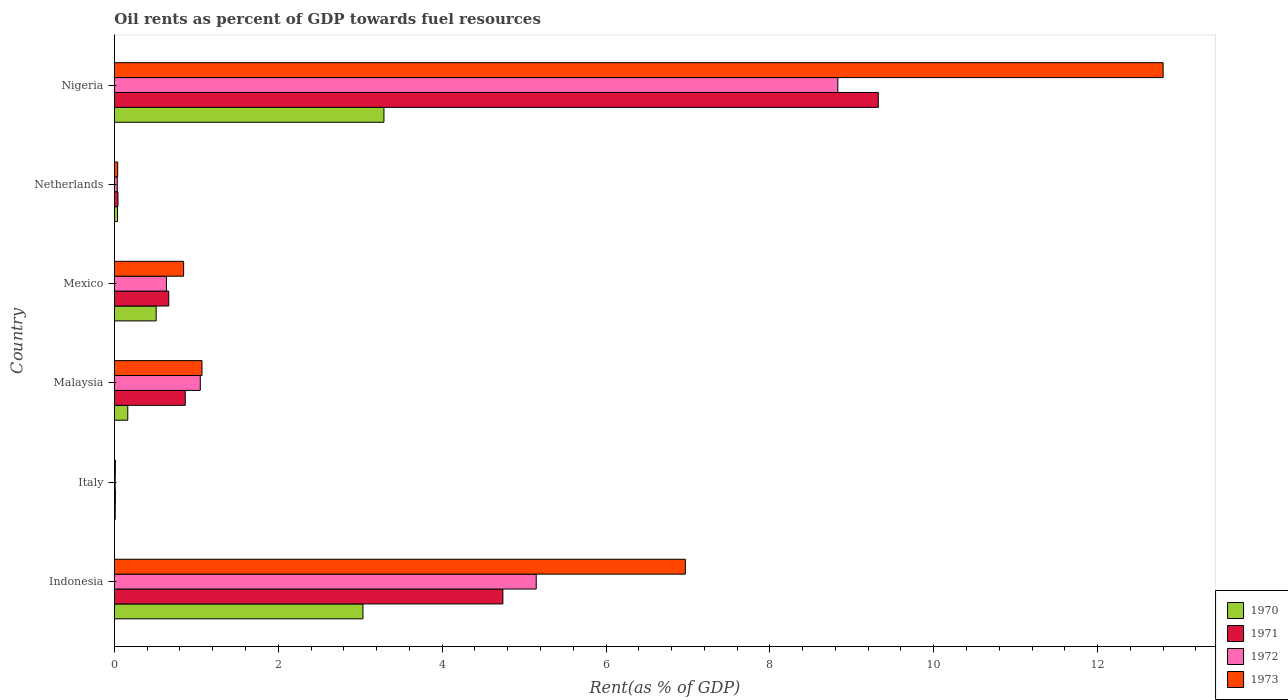How many different coloured bars are there?
Keep it short and to the point. 4. Are the number of bars per tick equal to the number of legend labels?
Provide a short and direct response. Yes. Are the number of bars on each tick of the Y-axis equal?
Your answer should be very brief. Yes. How many bars are there on the 3rd tick from the bottom?
Provide a short and direct response. 4. What is the label of the 3rd group of bars from the top?
Provide a succinct answer. Mexico. In how many cases, is the number of bars for a given country not equal to the number of legend labels?
Ensure brevity in your answer.  0. What is the oil rent in 1972 in Nigeria?
Your answer should be very brief. 8.83. Across all countries, what is the maximum oil rent in 1972?
Give a very brief answer. 8.83. Across all countries, what is the minimum oil rent in 1973?
Give a very brief answer. 0.01. In which country was the oil rent in 1973 maximum?
Offer a very short reply. Nigeria. What is the total oil rent in 1970 in the graph?
Your answer should be compact. 7.04. What is the difference between the oil rent in 1971 in Indonesia and that in Nigeria?
Give a very brief answer. -4.58. What is the difference between the oil rent in 1971 in Nigeria and the oil rent in 1970 in Malaysia?
Make the answer very short. 9.16. What is the average oil rent in 1971 per country?
Your answer should be very brief. 2.61. What is the difference between the oil rent in 1972 and oil rent in 1971 in Italy?
Make the answer very short. -0. In how many countries, is the oil rent in 1971 greater than 6 %?
Provide a short and direct response. 1. What is the ratio of the oil rent in 1971 in Indonesia to that in Italy?
Provide a short and direct response. 404.61. Is the difference between the oil rent in 1972 in Indonesia and Nigeria greater than the difference between the oil rent in 1971 in Indonesia and Nigeria?
Offer a very short reply. Yes. What is the difference between the highest and the second highest oil rent in 1972?
Your response must be concise. 3.68. What is the difference between the highest and the lowest oil rent in 1973?
Your response must be concise. 12.79. Is the sum of the oil rent in 1970 in Italy and Netherlands greater than the maximum oil rent in 1972 across all countries?
Your answer should be compact. No. What does the 3rd bar from the top in Nigeria represents?
Your answer should be compact. 1971. How many countries are there in the graph?
Your answer should be very brief. 6. What is the difference between two consecutive major ticks on the X-axis?
Your answer should be very brief. 2. Are the values on the major ticks of X-axis written in scientific E-notation?
Make the answer very short. No. Does the graph contain grids?
Give a very brief answer. No. Where does the legend appear in the graph?
Your answer should be compact. Bottom right. How many legend labels are there?
Offer a very short reply. 4. How are the legend labels stacked?
Your response must be concise. Vertical. What is the title of the graph?
Provide a short and direct response. Oil rents as percent of GDP towards fuel resources. Does "1965" appear as one of the legend labels in the graph?
Your answer should be very brief. No. What is the label or title of the X-axis?
Provide a succinct answer. Rent(as % of GDP). What is the label or title of the Y-axis?
Keep it short and to the point. Country. What is the Rent(as % of GDP) in 1970 in Indonesia?
Give a very brief answer. 3.03. What is the Rent(as % of GDP) in 1971 in Indonesia?
Your answer should be compact. 4.74. What is the Rent(as % of GDP) of 1972 in Indonesia?
Keep it short and to the point. 5.15. What is the Rent(as % of GDP) of 1973 in Indonesia?
Offer a very short reply. 6.97. What is the Rent(as % of GDP) in 1970 in Italy?
Ensure brevity in your answer.  0.01. What is the Rent(as % of GDP) in 1971 in Italy?
Your answer should be compact. 0.01. What is the Rent(as % of GDP) of 1972 in Italy?
Offer a very short reply. 0.01. What is the Rent(as % of GDP) of 1973 in Italy?
Keep it short and to the point. 0.01. What is the Rent(as % of GDP) of 1970 in Malaysia?
Your response must be concise. 0.16. What is the Rent(as % of GDP) in 1971 in Malaysia?
Keep it short and to the point. 0.86. What is the Rent(as % of GDP) of 1972 in Malaysia?
Offer a very short reply. 1.05. What is the Rent(as % of GDP) in 1973 in Malaysia?
Make the answer very short. 1.07. What is the Rent(as % of GDP) in 1970 in Mexico?
Give a very brief answer. 0.51. What is the Rent(as % of GDP) of 1971 in Mexico?
Offer a very short reply. 0.66. What is the Rent(as % of GDP) in 1972 in Mexico?
Offer a very short reply. 0.63. What is the Rent(as % of GDP) in 1973 in Mexico?
Provide a short and direct response. 0.84. What is the Rent(as % of GDP) in 1970 in Netherlands?
Offer a very short reply. 0.04. What is the Rent(as % of GDP) in 1971 in Netherlands?
Provide a short and direct response. 0.04. What is the Rent(as % of GDP) in 1972 in Netherlands?
Your answer should be very brief. 0.03. What is the Rent(as % of GDP) of 1973 in Netherlands?
Offer a very short reply. 0.04. What is the Rent(as % of GDP) of 1970 in Nigeria?
Provide a succinct answer. 3.29. What is the Rent(as % of GDP) in 1971 in Nigeria?
Keep it short and to the point. 9.32. What is the Rent(as % of GDP) in 1972 in Nigeria?
Your response must be concise. 8.83. What is the Rent(as % of GDP) of 1973 in Nigeria?
Your answer should be very brief. 12.8. Across all countries, what is the maximum Rent(as % of GDP) of 1970?
Offer a very short reply. 3.29. Across all countries, what is the maximum Rent(as % of GDP) of 1971?
Your response must be concise. 9.32. Across all countries, what is the maximum Rent(as % of GDP) of 1972?
Provide a succinct answer. 8.83. Across all countries, what is the maximum Rent(as % of GDP) in 1973?
Provide a short and direct response. 12.8. Across all countries, what is the minimum Rent(as % of GDP) of 1970?
Give a very brief answer. 0.01. Across all countries, what is the minimum Rent(as % of GDP) in 1971?
Provide a succinct answer. 0.01. Across all countries, what is the minimum Rent(as % of GDP) in 1972?
Give a very brief answer. 0.01. Across all countries, what is the minimum Rent(as % of GDP) in 1973?
Give a very brief answer. 0.01. What is the total Rent(as % of GDP) of 1970 in the graph?
Offer a terse response. 7.04. What is the total Rent(as % of GDP) in 1971 in the graph?
Provide a succinct answer. 15.65. What is the total Rent(as % of GDP) in 1972 in the graph?
Keep it short and to the point. 15.7. What is the total Rent(as % of GDP) in 1973 in the graph?
Provide a succinct answer. 21.73. What is the difference between the Rent(as % of GDP) of 1970 in Indonesia and that in Italy?
Keep it short and to the point. 3.02. What is the difference between the Rent(as % of GDP) of 1971 in Indonesia and that in Italy?
Give a very brief answer. 4.73. What is the difference between the Rent(as % of GDP) of 1972 in Indonesia and that in Italy?
Your response must be concise. 5.14. What is the difference between the Rent(as % of GDP) in 1973 in Indonesia and that in Italy?
Provide a succinct answer. 6.96. What is the difference between the Rent(as % of GDP) in 1970 in Indonesia and that in Malaysia?
Your response must be concise. 2.87. What is the difference between the Rent(as % of GDP) of 1971 in Indonesia and that in Malaysia?
Offer a terse response. 3.88. What is the difference between the Rent(as % of GDP) of 1972 in Indonesia and that in Malaysia?
Give a very brief answer. 4.1. What is the difference between the Rent(as % of GDP) in 1973 in Indonesia and that in Malaysia?
Your answer should be compact. 5.9. What is the difference between the Rent(as % of GDP) of 1970 in Indonesia and that in Mexico?
Ensure brevity in your answer.  2.52. What is the difference between the Rent(as % of GDP) in 1971 in Indonesia and that in Mexico?
Your answer should be very brief. 4.08. What is the difference between the Rent(as % of GDP) of 1972 in Indonesia and that in Mexico?
Your response must be concise. 4.51. What is the difference between the Rent(as % of GDP) of 1973 in Indonesia and that in Mexico?
Make the answer very short. 6.12. What is the difference between the Rent(as % of GDP) in 1970 in Indonesia and that in Netherlands?
Your response must be concise. 3. What is the difference between the Rent(as % of GDP) in 1971 in Indonesia and that in Netherlands?
Provide a short and direct response. 4.7. What is the difference between the Rent(as % of GDP) of 1972 in Indonesia and that in Netherlands?
Offer a terse response. 5.11. What is the difference between the Rent(as % of GDP) in 1973 in Indonesia and that in Netherlands?
Offer a terse response. 6.93. What is the difference between the Rent(as % of GDP) of 1970 in Indonesia and that in Nigeria?
Provide a succinct answer. -0.26. What is the difference between the Rent(as % of GDP) of 1971 in Indonesia and that in Nigeria?
Your answer should be compact. -4.58. What is the difference between the Rent(as % of GDP) in 1972 in Indonesia and that in Nigeria?
Make the answer very short. -3.68. What is the difference between the Rent(as % of GDP) in 1973 in Indonesia and that in Nigeria?
Provide a succinct answer. -5.83. What is the difference between the Rent(as % of GDP) of 1970 in Italy and that in Malaysia?
Provide a succinct answer. -0.15. What is the difference between the Rent(as % of GDP) in 1971 in Italy and that in Malaysia?
Your answer should be compact. -0.85. What is the difference between the Rent(as % of GDP) in 1972 in Italy and that in Malaysia?
Make the answer very short. -1.04. What is the difference between the Rent(as % of GDP) of 1973 in Italy and that in Malaysia?
Give a very brief answer. -1.06. What is the difference between the Rent(as % of GDP) in 1970 in Italy and that in Mexico?
Provide a short and direct response. -0.5. What is the difference between the Rent(as % of GDP) of 1971 in Italy and that in Mexico?
Your answer should be compact. -0.65. What is the difference between the Rent(as % of GDP) of 1972 in Italy and that in Mexico?
Make the answer very short. -0.63. What is the difference between the Rent(as % of GDP) of 1973 in Italy and that in Mexico?
Keep it short and to the point. -0.83. What is the difference between the Rent(as % of GDP) in 1970 in Italy and that in Netherlands?
Provide a short and direct response. -0.03. What is the difference between the Rent(as % of GDP) in 1971 in Italy and that in Netherlands?
Your answer should be very brief. -0.03. What is the difference between the Rent(as % of GDP) of 1972 in Italy and that in Netherlands?
Provide a succinct answer. -0.03. What is the difference between the Rent(as % of GDP) of 1973 in Italy and that in Netherlands?
Offer a terse response. -0.03. What is the difference between the Rent(as % of GDP) of 1970 in Italy and that in Nigeria?
Your response must be concise. -3.28. What is the difference between the Rent(as % of GDP) in 1971 in Italy and that in Nigeria?
Give a very brief answer. -9.31. What is the difference between the Rent(as % of GDP) in 1972 in Italy and that in Nigeria?
Keep it short and to the point. -8.82. What is the difference between the Rent(as % of GDP) of 1973 in Italy and that in Nigeria?
Keep it short and to the point. -12.79. What is the difference between the Rent(as % of GDP) of 1970 in Malaysia and that in Mexico?
Provide a short and direct response. -0.35. What is the difference between the Rent(as % of GDP) of 1971 in Malaysia and that in Mexico?
Give a very brief answer. 0.2. What is the difference between the Rent(as % of GDP) in 1972 in Malaysia and that in Mexico?
Offer a very short reply. 0.41. What is the difference between the Rent(as % of GDP) in 1973 in Malaysia and that in Mexico?
Your response must be concise. 0.22. What is the difference between the Rent(as % of GDP) in 1970 in Malaysia and that in Netherlands?
Your response must be concise. 0.13. What is the difference between the Rent(as % of GDP) in 1971 in Malaysia and that in Netherlands?
Provide a succinct answer. 0.82. What is the difference between the Rent(as % of GDP) of 1972 in Malaysia and that in Netherlands?
Give a very brief answer. 1.01. What is the difference between the Rent(as % of GDP) of 1973 in Malaysia and that in Netherlands?
Your response must be concise. 1.03. What is the difference between the Rent(as % of GDP) of 1970 in Malaysia and that in Nigeria?
Keep it short and to the point. -3.13. What is the difference between the Rent(as % of GDP) in 1971 in Malaysia and that in Nigeria?
Offer a terse response. -8.46. What is the difference between the Rent(as % of GDP) in 1972 in Malaysia and that in Nigeria?
Provide a succinct answer. -7.78. What is the difference between the Rent(as % of GDP) of 1973 in Malaysia and that in Nigeria?
Your response must be concise. -11.73. What is the difference between the Rent(as % of GDP) of 1970 in Mexico and that in Netherlands?
Give a very brief answer. 0.47. What is the difference between the Rent(as % of GDP) in 1971 in Mexico and that in Netherlands?
Keep it short and to the point. 0.62. What is the difference between the Rent(as % of GDP) of 1972 in Mexico and that in Netherlands?
Give a very brief answer. 0.6. What is the difference between the Rent(as % of GDP) in 1973 in Mexico and that in Netherlands?
Provide a short and direct response. 0.81. What is the difference between the Rent(as % of GDP) of 1970 in Mexico and that in Nigeria?
Your answer should be very brief. -2.78. What is the difference between the Rent(as % of GDP) in 1971 in Mexico and that in Nigeria?
Make the answer very short. -8.66. What is the difference between the Rent(as % of GDP) of 1972 in Mexico and that in Nigeria?
Make the answer very short. -8.19. What is the difference between the Rent(as % of GDP) of 1973 in Mexico and that in Nigeria?
Keep it short and to the point. -11.95. What is the difference between the Rent(as % of GDP) in 1970 in Netherlands and that in Nigeria?
Offer a terse response. -3.25. What is the difference between the Rent(as % of GDP) in 1971 in Netherlands and that in Nigeria?
Offer a terse response. -9.28. What is the difference between the Rent(as % of GDP) of 1972 in Netherlands and that in Nigeria?
Offer a very short reply. -8.79. What is the difference between the Rent(as % of GDP) of 1973 in Netherlands and that in Nigeria?
Your response must be concise. -12.76. What is the difference between the Rent(as % of GDP) of 1970 in Indonesia and the Rent(as % of GDP) of 1971 in Italy?
Give a very brief answer. 3.02. What is the difference between the Rent(as % of GDP) of 1970 in Indonesia and the Rent(as % of GDP) of 1972 in Italy?
Your answer should be very brief. 3.02. What is the difference between the Rent(as % of GDP) in 1970 in Indonesia and the Rent(as % of GDP) in 1973 in Italy?
Provide a short and direct response. 3.02. What is the difference between the Rent(as % of GDP) of 1971 in Indonesia and the Rent(as % of GDP) of 1972 in Italy?
Offer a terse response. 4.73. What is the difference between the Rent(as % of GDP) in 1971 in Indonesia and the Rent(as % of GDP) in 1973 in Italy?
Your response must be concise. 4.73. What is the difference between the Rent(as % of GDP) of 1972 in Indonesia and the Rent(as % of GDP) of 1973 in Italy?
Your answer should be very brief. 5.14. What is the difference between the Rent(as % of GDP) of 1970 in Indonesia and the Rent(as % of GDP) of 1971 in Malaysia?
Provide a short and direct response. 2.17. What is the difference between the Rent(as % of GDP) of 1970 in Indonesia and the Rent(as % of GDP) of 1972 in Malaysia?
Provide a succinct answer. 1.99. What is the difference between the Rent(as % of GDP) of 1970 in Indonesia and the Rent(as % of GDP) of 1973 in Malaysia?
Provide a succinct answer. 1.96. What is the difference between the Rent(as % of GDP) of 1971 in Indonesia and the Rent(as % of GDP) of 1972 in Malaysia?
Offer a very short reply. 3.69. What is the difference between the Rent(as % of GDP) of 1971 in Indonesia and the Rent(as % of GDP) of 1973 in Malaysia?
Your response must be concise. 3.67. What is the difference between the Rent(as % of GDP) in 1972 in Indonesia and the Rent(as % of GDP) in 1973 in Malaysia?
Your answer should be very brief. 4.08. What is the difference between the Rent(as % of GDP) of 1970 in Indonesia and the Rent(as % of GDP) of 1971 in Mexico?
Provide a succinct answer. 2.37. What is the difference between the Rent(as % of GDP) of 1970 in Indonesia and the Rent(as % of GDP) of 1972 in Mexico?
Your answer should be compact. 2.4. What is the difference between the Rent(as % of GDP) of 1970 in Indonesia and the Rent(as % of GDP) of 1973 in Mexico?
Provide a succinct answer. 2.19. What is the difference between the Rent(as % of GDP) of 1971 in Indonesia and the Rent(as % of GDP) of 1972 in Mexico?
Provide a succinct answer. 4.11. What is the difference between the Rent(as % of GDP) in 1971 in Indonesia and the Rent(as % of GDP) in 1973 in Mexico?
Ensure brevity in your answer.  3.9. What is the difference between the Rent(as % of GDP) in 1972 in Indonesia and the Rent(as % of GDP) in 1973 in Mexico?
Make the answer very short. 4.3. What is the difference between the Rent(as % of GDP) in 1970 in Indonesia and the Rent(as % of GDP) in 1971 in Netherlands?
Your answer should be very brief. 2.99. What is the difference between the Rent(as % of GDP) in 1970 in Indonesia and the Rent(as % of GDP) in 1972 in Netherlands?
Your answer should be compact. 3. What is the difference between the Rent(as % of GDP) in 1970 in Indonesia and the Rent(as % of GDP) in 1973 in Netherlands?
Ensure brevity in your answer.  2.99. What is the difference between the Rent(as % of GDP) of 1971 in Indonesia and the Rent(as % of GDP) of 1972 in Netherlands?
Give a very brief answer. 4.71. What is the difference between the Rent(as % of GDP) in 1971 in Indonesia and the Rent(as % of GDP) in 1973 in Netherlands?
Give a very brief answer. 4.7. What is the difference between the Rent(as % of GDP) of 1972 in Indonesia and the Rent(as % of GDP) of 1973 in Netherlands?
Your response must be concise. 5.11. What is the difference between the Rent(as % of GDP) of 1970 in Indonesia and the Rent(as % of GDP) of 1971 in Nigeria?
Ensure brevity in your answer.  -6.29. What is the difference between the Rent(as % of GDP) in 1970 in Indonesia and the Rent(as % of GDP) in 1972 in Nigeria?
Keep it short and to the point. -5.8. What is the difference between the Rent(as % of GDP) in 1970 in Indonesia and the Rent(as % of GDP) in 1973 in Nigeria?
Provide a succinct answer. -9.77. What is the difference between the Rent(as % of GDP) in 1971 in Indonesia and the Rent(as % of GDP) in 1972 in Nigeria?
Your answer should be compact. -4.09. What is the difference between the Rent(as % of GDP) in 1971 in Indonesia and the Rent(as % of GDP) in 1973 in Nigeria?
Make the answer very short. -8.06. What is the difference between the Rent(as % of GDP) in 1972 in Indonesia and the Rent(as % of GDP) in 1973 in Nigeria?
Your answer should be compact. -7.65. What is the difference between the Rent(as % of GDP) of 1970 in Italy and the Rent(as % of GDP) of 1971 in Malaysia?
Provide a short and direct response. -0.85. What is the difference between the Rent(as % of GDP) in 1970 in Italy and the Rent(as % of GDP) in 1972 in Malaysia?
Ensure brevity in your answer.  -1.04. What is the difference between the Rent(as % of GDP) in 1970 in Italy and the Rent(as % of GDP) in 1973 in Malaysia?
Make the answer very short. -1.06. What is the difference between the Rent(as % of GDP) of 1971 in Italy and the Rent(as % of GDP) of 1972 in Malaysia?
Your answer should be compact. -1.04. What is the difference between the Rent(as % of GDP) in 1971 in Italy and the Rent(as % of GDP) in 1973 in Malaysia?
Provide a short and direct response. -1.06. What is the difference between the Rent(as % of GDP) of 1972 in Italy and the Rent(as % of GDP) of 1973 in Malaysia?
Your answer should be very brief. -1.06. What is the difference between the Rent(as % of GDP) of 1970 in Italy and the Rent(as % of GDP) of 1971 in Mexico?
Offer a terse response. -0.65. What is the difference between the Rent(as % of GDP) of 1970 in Italy and the Rent(as % of GDP) of 1972 in Mexico?
Make the answer very short. -0.62. What is the difference between the Rent(as % of GDP) of 1970 in Italy and the Rent(as % of GDP) of 1973 in Mexico?
Offer a very short reply. -0.83. What is the difference between the Rent(as % of GDP) of 1971 in Italy and the Rent(as % of GDP) of 1972 in Mexico?
Your answer should be very brief. -0.62. What is the difference between the Rent(as % of GDP) in 1971 in Italy and the Rent(as % of GDP) in 1973 in Mexico?
Offer a terse response. -0.83. What is the difference between the Rent(as % of GDP) of 1972 in Italy and the Rent(as % of GDP) of 1973 in Mexico?
Provide a short and direct response. -0.84. What is the difference between the Rent(as % of GDP) of 1970 in Italy and the Rent(as % of GDP) of 1971 in Netherlands?
Your answer should be compact. -0.03. What is the difference between the Rent(as % of GDP) in 1970 in Italy and the Rent(as % of GDP) in 1972 in Netherlands?
Provide a succinct answer. -0.02. What is the difference between the Rent(as % of GDP) of 1970 in Italy and the Rent(as % of GDP) of 1973 in Netherlands?
Your answer should be very brief. -0.03. What is the difference between the Rent(as % of GDP) of 1971 in Italy and the Rent(as % of GDP) of 1972 in Netherlands?
Offer a very short reply. -0.02. What is the difference between the Rent(as % of GDP) of 1971 in Italy and the Rent(as % of GDP) of 1973 in Netherlands?
Make the answer very short. -0.03. What is the difference between the Rent(as % of GDP) of 1972 in Italy and the Rent(as % of GDP) of 1973 in Netherlands?
Your response must be concise. -0.03. What is the difference between the Rent(as % of GDP) in 1970 in Italy and the Rent(as % of GDP) in 1971 in Nigeria?
Keep it short and to the point. -9.31. What is the difference between the Rent(as % of GDP) in 1970 in Italy and the Rent(as % of GDP) in 1972 in Nigeria?
Provide a succinct answer. -8.82. What is the difference between the Rent(as % of GDP) in 1970 in Italy and the Rent(as % of GDP) in 1973 in Nigeria?
Offer a terse response. -12.79. What is the difference between the Rent(as % of GDP) in 1971 in Italy and the Rent(as % of GDP) in 1972 in Nigeria?
Your answer should be very brief. -8.82. What is the difference between the Rent(as % of GDP) in 1971 in Italy and the Rent(as % of GDP) in 1973 in Nigeria?
Offer a very short reply. -12.79. What is the difference between the Rent(as % of GDP) in 1972 in Italy and the Rent(as % of GDP) in 1973 in Nigeria?
Your answer should be compact. -12.79. What is the difference between the Rent(as % of GDP) of 1970 in Malaysia and the Rent(as % of GDP) of 1971 in Mexico?
Your response must be concise. -0.5. What is the difference between the Rent(as % of GDP) in 1970 in Malaysia and the Rent(as % of GDP) in 1972 in Mexico?
Offer a terse response. -0.47. What is the difference between the Rent(as % of GDP) in 1970 in Malaysia and the Rent(as % of GDP) in 1973 in Mexico?
Offer a very short reply. -0.68. What is the difference between the Rent(as % of GDP) of 1971 in Malaysia and the Rent(as % of GDP) of 1972 in Mexico?
Offer a terse response. 0.23. What is the difference between the Rent(as % of GDP) in 1971 in Malaysia and the Rent(as % of GDP) in 1973 in Mexico?
Offer a terse response. 0.02. What is the difference between the Rent(as % of GDP) of 1972 in Malaysia and the Rent(as % of GDP) of 1973 in Mexico?
Ensure brevity in your answer.  0.2. What is the difference between the Rent(as % of GDP) in 1970 in Malaysia and the Rent(as % of GDP) in 1971 in Netherlands?
Your response must be concise. 0.12. What is the difference between the Rent(as % of GDP) in 1970 in Malaysia and the Rent(as % of GDP) in 1972 in Netherlands?
Ensure brevity in your answer.  0.13. What is the difference between the Rent(as % of GDP) in 1970 in Malaysia and the Rent(as % of GDP) in 1973 in Netherlands?
Give a very brief answer. 0.12. What is the difference between the Rent(as % of GDP) in 1971 in Malaysia and the Rent(as % of GDP) in 1972 in Netherlands?
Ensure brevity in your answer.  0.83. What is the difference between the Rent(as % of GDP) in 1971 in Malaysia and the Rent(as % of GDP) in 1973 in Netherlands?
Give a very brief answer. 0.82. What is the difference between the Rent(as % of GDP) in 1972 in Malaysia and the Rent(as % of GDP) in 1973 in Netherlands?
Make the answer very short. 1.01. What is the difference between the Rent(as % of GDP) in 1970 in Malaysia and the Rent(as % of GDP) in 1971 in Nigeria?
Keep it short and to the point. -9.16. What is the difference between the Rent(as % of GDP) in 1970 in Malaysia and the Rent(as % of GDP) in 1972 in Nigeria?
Give a very brief answer. -8.67. What is the difference between the Rent(as % of GDP) in 1970 in Malaysia and the Rent(as % of GDP) in 1973 in Nigeria?
Offer a terse response. -12.64. What is the difference between the Rent(as % of GDP) of 1971 in Malaysia and the Rent(as % of GDP) of 1972 in Nigeria?
Your answer should be compact. -7.96. What is the difference between the Rent(as % of GDP) in 1971 in Malaysia and the Rent(as % of GDP) in 1973 in Nigeria?
Offer a very short reply. -11.94. What is the difference between the Rent(as % of GDP) of 1972 in Malaysia and the Rent(as % of GDP) of 1973 in Nigeria?
Make the answer very short. -11.75. What is the difference between the Rent(as % of GDP) in 1970 in Mexico and the Rent(as % of GDP) in 1971 in Netherlands?
Give a very brief answer. 0.47. What is the difference between the Rent(as % of GDP) in 1970 in Mexico and the Rent(as % of GDP) in 1972 in Netherlands?
Keep it short and to the point. 0.47. What is the difference between the Rent(as % of GDP) in 1970 in Mexico and the Rent(as % of GDP) in 1973 in Netherlands?
Give a very brief answer. 0.47. What is the difference between the Rent(as % of GDP) of 1971 in Mexico and the Rent(as % of GDP) of 1972 in Netherlands?
Provide a short and direct response. 0.63. What is the difference between the Rent(as % of GDP) in 1971 in Mexico and the Rent(as % of GDP) in 1973 in Netherlands?
Give a very brief answer. 0.62. What is the difference between the Rent(as % of GDP) in 1972 in Mexico and the Rent(as % of GDP) in 1973 in Netherlands?
Your answer should be compact. 0.6. What is the difference between the Rent(as % of GDP) of 1970 in Mexico and the Rent(as % of GDP) of 1971 in Nigeria?
Your response must be concise. -8.81. What is the difference between the Rent(as % of GDP) in 1970 in Mexico and the Rent(as % of GDP) in 1972 in Nigeria?
Your answer should be compact. -8.32. What is the difference between the Rent(as % of GDP) in 1970 in Mexico and the Rent(as % of GDP) in 1973 in Nigeria?
Your response must be concise. -12.29. What is the difference between the Rent(as % of GDP) in 1971 in Mexico and the Rent(as % of GDP) in 1972 in Nigeria?
Ensure brevity in your answer.  -8.17. What is the difference between the Rent(as % of GDP) of 1971 in Mexico and the Rent(as % of GDP) of 1973 in Nigeria?
Provide a short and direct response. -12.14. What is the difference between the Rent(as % of GDP) of 1972 in Mexico and the Rent(as % of GDP) of 1973 in Nigeria?
Offer a very short reply. -12.16. What is the difference between the Rent(as % of GDP) of 1970 in Netherlands and the Rent(as % of GDP) of 1971 in Nigeria?
Your response must be concise. -9.29. What is the difference between the Rent(as % of GDP) in 1970 in Netherlands and the Rent(as % of GDP) in 1972 in Nigeria?
Your response must be concise. -8.79. What is the difference between the Rent(as % of GDP) of 1970 in Netherlands and the Rent(as % of GDP) of 1973 in Nigeria?
Make the answer very short. -12.76. What is the difference between the Rent(as % of GDP) of 1971 in Netherlands and the Rent(as % of GDP) of 1972 in Nigeria?
Your answer should be very brief. -8.79. What is the difference between the Rent(as % of GDP) of 1971 in Netherlands and the Rent(as % of GDP) of 1973 in Nigeria?
Make the answer very short. -12.76. What is the difference between the Rent(as % of GDP) in 1972 in Netherlands and the Rent(as % of GDP) in 1973 in Nigeria?
Provide a short and direct response. -12.76. What is the average Rent(as % of GDP) of 1970 per country?
Your response must be concise. 1.17. What is the average Rent(as % of GDP) of 1971 per country?
Give a very brief answer. 2.61. What is the average Rent(as % of GDP) of 1972 per country?
Your answer should be compact. 2.62. What is the average Rent(as % of GDP) in 1973 per country?
Give a very brief answer. 3.62. What is the difference between the Rent(as % of GDP) in 1970 and Rent(as % of GDP) in 1971 in Indonesia?
Ensure brevity in your answer.  -1.71. What is the difference between the Rent(as % of GDP) of 1970 and Rent(as % of GDP) of 1972 in Indonesia?
Keep it short and to the point. -2.11. What is the difference between the Rent(as % of GDP) in 1970 and Rent(as % of GDP) in 1973 in Indonesia?
Offer a very short reply. -3.93. What is the difference between the Rent(as % of GDP) in 1971 and Rent(as % of GDP) in 1972 in Indonesia?
Provide a short and direct response. -0.41. What is the difference between the Rent(as % of GDP) of 1971 and Rent(as % of GDP) of 1973 in Indonesia?
Keep it short and to the point. -2.23. What is the difference between the Rent(as % of GDP) in 1972 and Rent(as % of GDP) in 1973 in Indonesia?
Make the answer very short. -1.82. What is the difference between the Rent(as % of GDP) of 1970 and Rent(as % of GDP) of 1971 in Italy?
Provide a short and direct response. -0. What is the difference between the Rent(as % of GDP) in 1970 and Rent(as % of GDP) in 1972 in Italy?
Your answer should be very brief. 0. What is the difference between the Rent(as % of GDP) of 1970 and Rent(as % of GDP) of 1973 in Italy?
Provide a succinct answer. -0. What is the difference between the Rent(as % of GDP) in 1971 and Rent(as % of GDP) in 1972 in Italy?
Ensure brevity in your answer.  0. What is the difference between the Rent(as % of GDP) in 1972 and Rent(as % of GDP) in 1973 in Italy?
Provide a short and direct response. -0. What is the difference between the Rent(as % of GDP) of 1970 and Rent(as % of GDP) of 1971 in Malaysia?
Your answer should be compact. -0.7. What is the difference between the Rent(as % of GDP) of 1970 and Rent(as % of GDP) of 1972 in Malaysia?
Provide a succinct answer. -0.89. What is the difference between the Rent(as % of GDP) in 1970 and Rent(as % of GDP) in 1973 in Malaysia?
Your response must be concise. -0.91. What is the difference between the Rent(as % of GDP) of 1971 and Rent(as % of GDP) of 1972 in Malaysia?
Make the answer very short. -0.18. What is the difference between the Rent(as % of GDP) in 1971 and Rent(as % of GDP) in 1973 in Malaysia?
Provide a succinct answer. -0.2. What is the difference between the Rent(as % of GDP) in 1972 and Rent(as % of GDP) in 1973 in Malaysia?
Your answer should be compact. -0.02. What is the difference between the Rent(as % of GDP) of 1970 and Rent(as % of GDP) of 1971 in Mexico?
Provide a succinct answer. -0.15. What is the difference between the Rent(as % of GDP) in 1970 and Rent(as % of GDP) in 1972 in Mexico?
Give a very brief answer. -0.13. What is the difference between the Rent(as % of GDP) of 1970 and Rent(as % of GDP) of 1973 in Mexico?
Your response must be concise. -0.34. What is the difference between the Rent(as % of GDP) of 1971 and Rent(as % of GDP) of 1972 in Mexico?
Ensure brevity in your answer.  0.03. What is the difference between the Rent(as % of GDP) in 1971 and Rent(as % of GDP) in 1973 in Mexico?
Provide a succinct answer. -0.18. What is the difference between the Rent(as % of GDP) in 1972 and Rent(as % of GDP) in 1973 in Mexico?
Provide a succinct answer. -0.21. What is the difference between the Rent(as % of GDP) in 1970 and Rent(as % of GDP) in 1971 in Netherlands?
Provide a short and direct response. -0.01. What is the difference between the Rent(as % of GDP) of 1970 and Rent(as % of GDP) of 1972 in Netherlands?
Provide a succinct answer. 0. What is the difference between the Rent(as % of GDP) in 1970 and Rent(as % of GDP) in 1973 in Netherlands?
Offer a very short reply. -0. What is the difference between the Rent(as % of GDP) in 1971 and Rent(as % of GDP) in 1972 in Netherlands?
Your answer should be very brief. 0.01. What is the difference between the Rent(as % of GDP) in 1971 and Rent(as % of GDP) in 1973 in Netherlands?
Offer a very short reply. 0. What is the difference between the Rent(as % of GDP) in 1972 and Rent(as % of GDP) in 1973 in Netherlands?
Offer a terse response. -0. What is the difference between the Rent(as % of GDP) in 1970 and Rent(as % of GDP) in 1971 in Nigeria?
Offer a terse response. -6.03. What is the difference between the Rent(as % of GDP) in 1970 and Rent(as % of GDP) in 1972 in Nigeria?
Make the answer very short. -5.54. What is the difference between the Rent(as % of GDP) in 1970 and Rent(as % of GDP) in 1973 in Nigeria?
Offer a terse response. -9.51. What is the difference between the Rent(as % of GDP) in 1971 and Rent(as % of GDP) in 1972 in Nigeria?
Keep it short and to the point. 0.49. What is the difference between the Rent(as % of GDP) in 1971 and Rent(as % of GDP) in 1973 in Nigeria?
Offer a very short reply. -3.48. What is the difference between the Rent(as % of GDP) of 1972 and Rent(as % of GDP) of 1973 in Nigeria?
Offer a terse response. -3.97. What is the ratio of the Rent(as % of GDP) of 1970 in Indonesia to that in Italy?
Keep it short and to the point. 307.81. What is the ratio of the Rent(as % of GDP) in 1971 in Indonesia to that in Italy?
Give a very brief answer. 404.61. What is the ratio of the Rent(as % of GDP) in 1972 in Indonesia to that in Italy?
Provide a short and direct response. 553.4. What is the ratio of the Rent(as % of GDP) in 1973 in Indonesia to that in Italy?
Give a very brief answer. 622.04. What is the ratio of the Rent(as % of GDP) in 1970 in Indonesia to that in Malaysia?
Your response must be concise. 18.61. What is the ratio of the Rent(as % of GDP) of 1971 in Indonesia to that in Malaysia?
Provide a short and direct response. 5.48. What is the ratio of the Rent(as % of GDP) of 1972 in Indonesia to that in Malaysia?
Provide a succinct answer. 4.91. What is the ratio of the Rent(as % of GDP) of 1973 in Indonesia to that in Malaysia?
Give a very brief answer. 6.52. What is the ratio of the Rent(as % of GDP) in 1970 in Indonesia to that in Mexico?
Your response must be concise. 5.95. What is the ratio of the Rent(as % of GDP) of 1971 in Indonesia to that in Mexico?
Provide a short and direct response. 7.15. What is the ratio of the Rent(as % of GDP) of 1972 in Indonesia to that in Mexico?
Keep it short and to the point. 8.11. What is the ratio of the Rent(as % of GDP) in 1973 in Indonesia to that in Mexico?
Give a very brief answer. 8.25. What is the ratio of the Rent(as % of GDP) in 1970 in Indonesia to that in Netherlands?
Make the answer very short. 79.97. What is the ratio of the Rent(as % of GDP) in 1971 in Indonesia to that in Netherlands?
Provide a short and direct response. 109.89. What is the ratio of the Rent(as % of GDP) of 1972 in Indonesia to that in Netherlands?
Ensure brevity in your answer.  148.28. What is the ratio of the Rent(as % of GDP) of 1973 in Indonesia to that in Netherlands?
Your answer should be very brief. 176.41. What is the ratio of the Rent(as % of GDP) of 1970 in Indonesia to that in Nigeria?
Offer a very short reply. 0.92. What is the ratio of the Rent(as % of GDP) of 1971 in Indonesia to that in Nigeria?
Give a very brief answer. 0.51. What is the ratio of the Rent(as % of GDP) in 1972 in Indonesia to that in Nigeria?
Make the answer very short. 0.58. What is the ratio of the Rent(as % of GDP) of 1973 in Indonesia to that in Nigeria?
Give a very brief answer. 0.54. What is the ratio of the Rent(as % of GDP) of 1970 in Italy to that in Malaysia?
Give a very brief answer. 0.06. What is the ratio of the Rent(as % of GDP) in 1971 in Italy to that in Malaysia?
Keep it short and to the point. 0.01. What is the ratio of the Rent(as % of GDP) in 1972 in Italy to that in Malaysia?
Give a very brief answer. 0.01. What is the ratio of the Rent(as % of GDP) of 1973 in Italy to that in Malaysia?
Offer a very short reply. 0.01. What is the ratio of the Rent(as % of GDP) of 1970 in Italy to that in Mexico?
Give a very brief answer. 0.02. What is the ratio of the Rent(as % of GDP) of 1971 in Italy to that in Mexico?
Make the answer very short. 0.02. What is the ratio of the Rent(as % of GDP) in 1972 in Italy to that in Mexico?
Your answer should be compact. 0.01. What is the ratio of the Rent(as % of GDP) of 1973 in Italy to that in Mexico?
Your answer should be very brief. 0.01. What is the ratio of the Rent(as % of GDP) in 1970 in Italy to that in Netherlands?
Your response must be concise. 0.26. What is the ratio of the Rent(as % of GDP) of 1971 in Italy to that in Netherlands?
Your answer should be very brief. 0.27. What is the ratio of the Rent(as % of GDP) in 1972 in Italy to that in Netherlands?
Offer a terse response. 0.27. What is the ratio of the Rent(as % of GDP) of 1973 in Italy to that in Netherlands?
Offer a terse response. 0.28. What is the ratio of the Rent(as % of GDP) in 1970 in Italy to that in Nigeria?
Make the answer very short. 0. What is the ratio of the Rent(as % of GDP) of 1971 in Italy to that in Nigeria?
Provide a short and direct response. 0. What is the ratio of the Rent(as % of GDP) of 1972 in Italy to that in Nigeria?
Ensure brevity in your answer.  0. What is the ratio of the Rent(as % of GDP) of 1973 in Italy to that in Nigeria?
Ensure brevity in your answer.  0. What is the ratio of the Rent(as % of GDP) in 1970 in Malaysia to that in Mexico?
Provide a short and direct response. 0.32. What is the ratio of the Rent(as % of GDP) of 1971 in Malaysia to that in Mexico?
Make the answer very short. 1.3. What is the ratio of the Rent(as % of GDP) of 1972 in Malaysia to that in Mexico?
Your answer should be very brief. 1.65. What is the ratio of the Rent(as % of GDP) of 1973 in Malaysia to that in Mexico?
Provide a succinct answer. 1.27. What is the ratio of the Rent(as % of GDP) in 1970 in Malaysia to that in Netherlands?
Your response must be concise. 4.3. What is the ratio of the Rent(as % of GDP) of 1971 in Malaysia to that in Netherlands?
Keep it short and to the point. 20.04. What is the ratio of the Rent(as % of GDP) in 1972 in Malaysia to that in Netherlands?
Make the answer very short. 30.19. What is the ratio of the Rent(as % of GDP) of 1973 in Malaysia to that in Netherlands?
Ensure brevity in your answer.  27.06. What is the ratio of the Rent(as % of GDP) in 1970 in Malaysia to that in Nigeria?
Keep it short and to the point. 0.05. What is the ratio of the Rent(as % of GDP) in 1971 in Malaysia to that in Nigeria?
Ensure brevity in your answer.  0.09. What is the ratio of the Rent(as % of GDP) of 1972 in Malaysia to that in Nigeria?
Provide a succinct answer. 0.12. What is the ratio of the Rent(as % of GDP) of 1973 in Malaysia to that in Nigeria?
Provide a succinct answer. 0.08. What is the ratio of the Rent(as % of GDP) in 1970 in Mexico to that in Netherlands?
Ensure brevity in your answer.  13.43. What is the ratio of the Rent(as % of GDP) of 1971 in Mexico to that in Netherlands?
Make the answer very short. 15.37. What is the ratio of the Rent(as % of GDP) in 1972 in Mexico to that in Netherlands?
Your answer should be compact. 18.28. What is the ratio of the Rent(as % of GDP) of 1973 in Mexico to that in Netherlands?
Your answer should be very brief. 21.38. What is the ratio of the Rent(as % of GDP) in 1970 in Mexico to that in Nigeria?
Give a very brief answer. 0.15. What is the ratio of the Rent(as % of GDP) in 1971 in Mexico to that in Nigeria?
Give a very brief answer. 0.07. What is the ratio of the Rent(as % of GDP) of 1972 in Mexico to that in Nigeria?
Make the answer very short. 0.07. What is the ratio of the Rent(as % of GDP) of 1973 in Mexico to that in Nigeria?
Provide a short and direct response. 0.07. What is the ratio of the Rent(as % of GDP) in 1970 in Netherlands to that in Nigeria?
Your answer should be very brief. 0.01. What is the ratio of the Rent(as % of GDP) in 1971 in Netherlands to that in Nigeria?
Give a very brief answer. 0. What is the ratio of the Rent(as % of GDP) in 1972 in Netherlands to that in Nigeria?
Give a very brief answer. 0. What is the ratio of the Rent(as % of GDP) in 1973 in Netherlands to that in Nigeria?
Offer a very short reply. 0. What is the difference between the highest and the second highest Rent(as % of GDP) in 1970?
Provide a succinct answer. 0.26. What is the difference between the highest and the second highest Rent(as % of GDP) of 1971?
Your answer should be compact. 4.58. What is the difference between the highest and the second highest Rent(as % of GDP) of 1972?
Offer a terse response. 3.68. What is the difference between the highest and the second highest Rent(as % of GDP) of 1973?
Your response must be concise. 5.83. What is the difference between the highest and the lowest Rent(as % of GDP) in 1970?
Keep it short and to the point. 3.28. What is the difference between the highest and the lowest Rent(as % of GDP) of 1971?
Your answer should be very brief. 9.31. What is the difference between the highest and the lowest Rent(as % of GDP) in 1972?
Offer a very short reply. 8.82. What is the difference between the highest and the lowest Rent(as % of GDP) of 1973?
Keep it short and to the point. 12.79. 